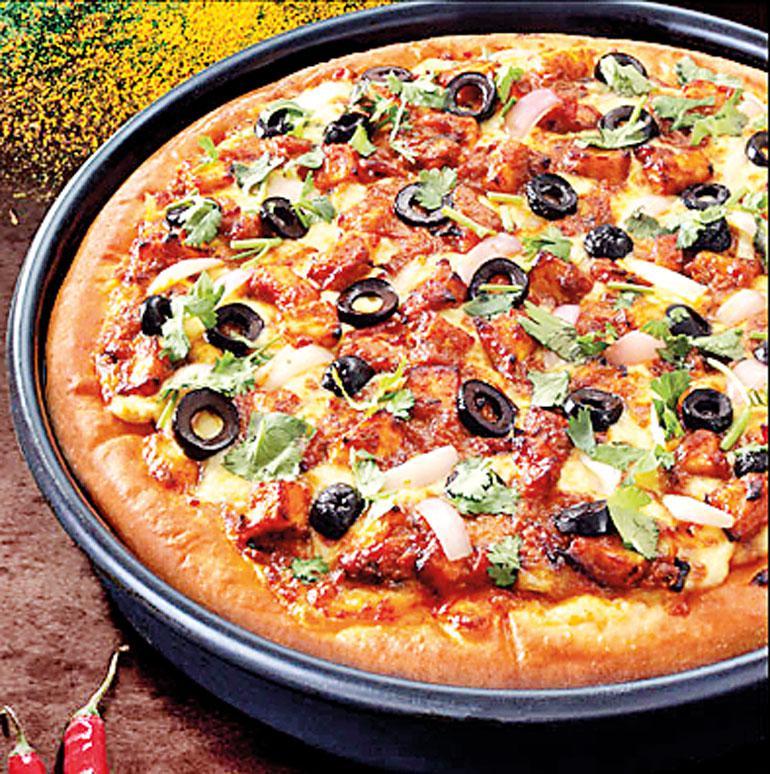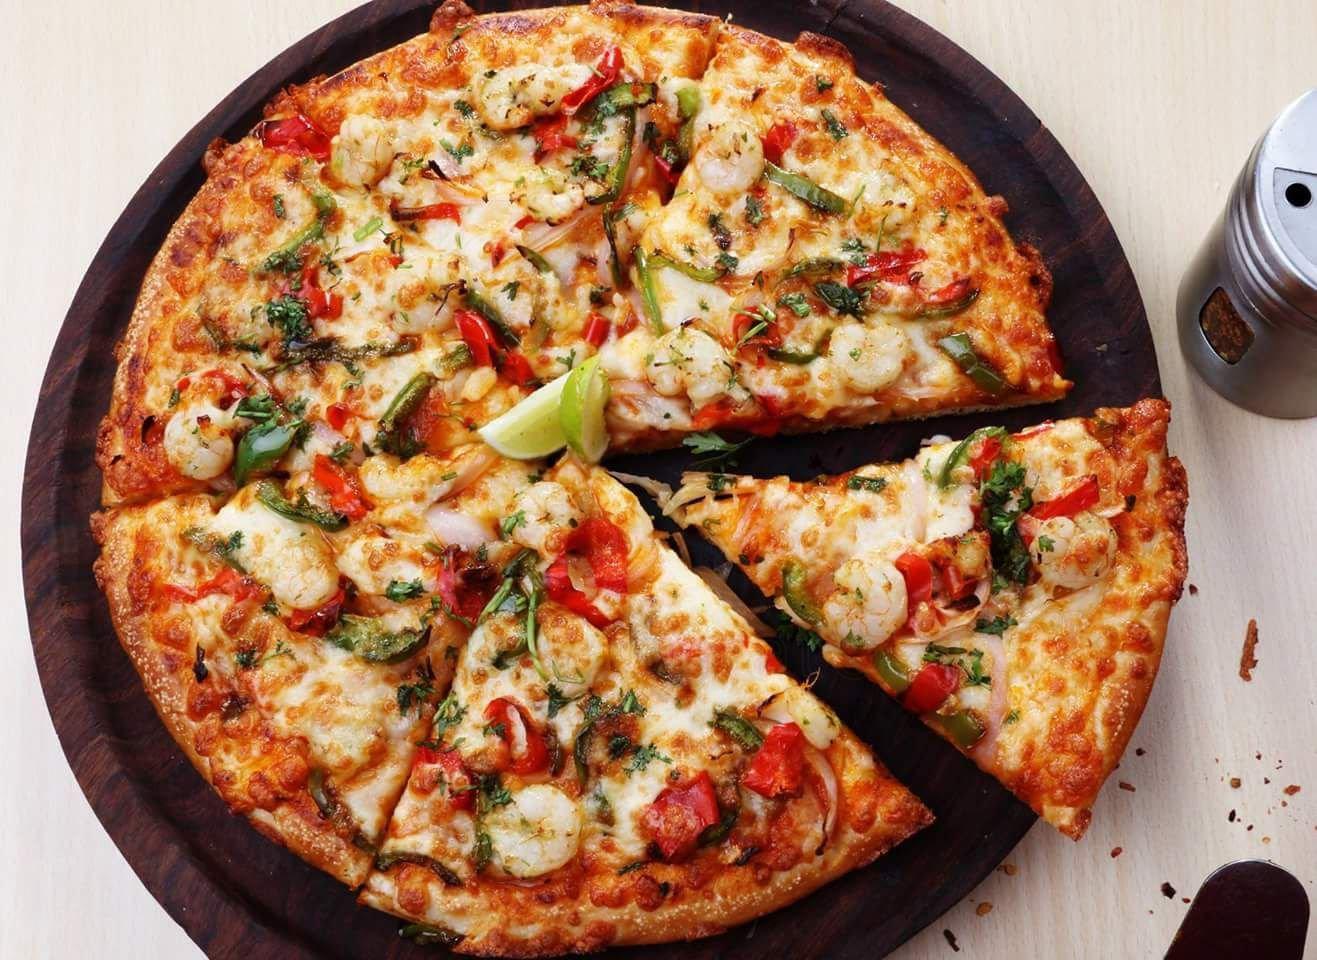The first image is the image on the left, the second image is the image on the right. For the images shown, is this caption "There are no more than 2 pizzas." true? Answer yes or no. Yes. The first image is the image on the left, the second image is the image on the right. Examine the images to the left and right. Is the description "There are exactly two pizzas." accurate? Answer yes or no. Yes. 